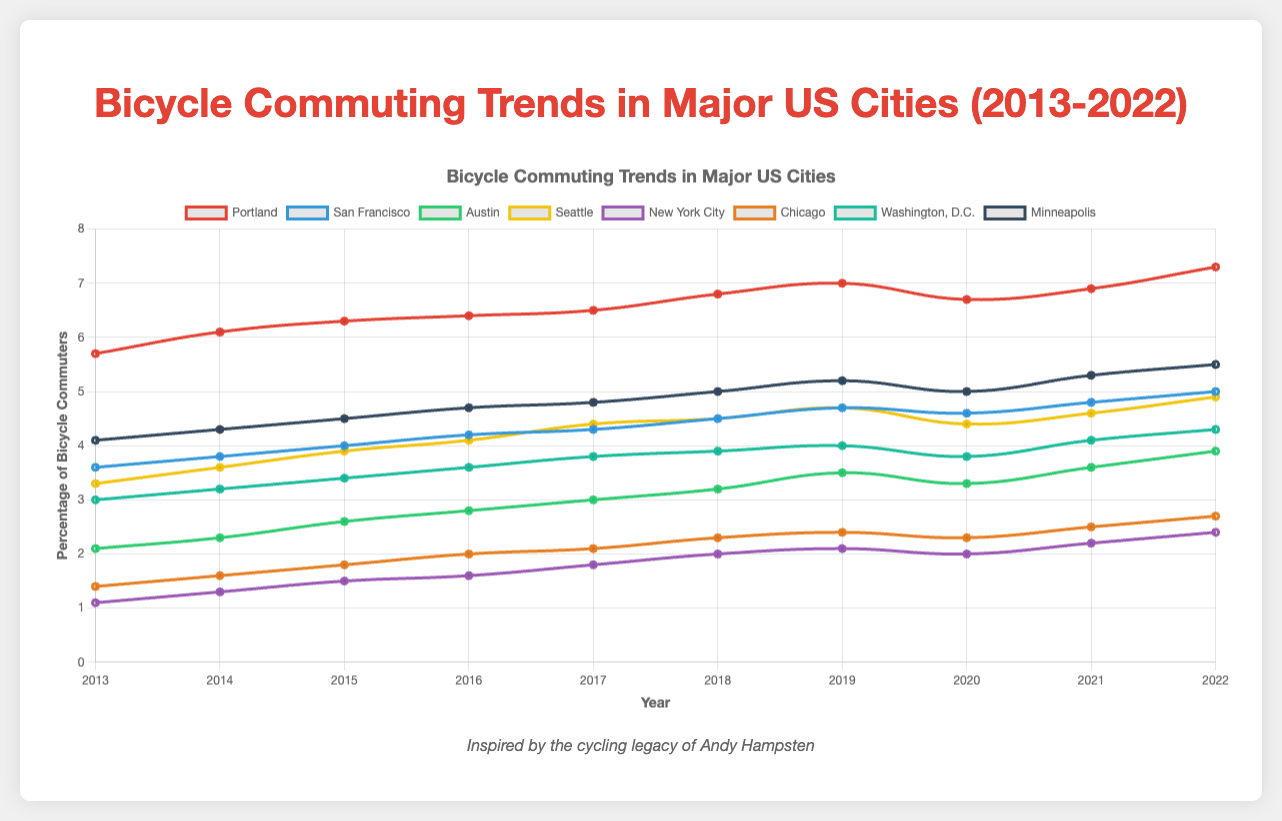What city shows the highest percentage of bicycle commuters in 2022? Look at the end points of all the lines on the right side of the graph. Portland has the highest percentage in 2022 which is 7.3%.
Answer: Portland How did the bicycle commuting rates change in San Francisco from 2013 to 2022? Compare the starting point in 2013 (3.6%) with the ending point in 2022 (5.0%) for San Francisco. The rate increased from 3.6% to 5.0%.
Answer: Increased from 3.6% to 5.0% Which city experienced the biggest drop in bicycle commuting rates in any given year? Check for the biggest single-year decrease in the lines. Portland had the biggest drop from 7.0% in 2019 to 6.7% in 2020.
Answer: Portland Between 2016 and 2018, which city had the highest average bicycle commuting rate? Identify the rates for 2016, 2017, and 2018 for each city, sum them up, and divide by 3. Portland's average is the highest at (6.4% + 6.5% + 6.8%) / 3 = 6.57%.
Answer: Portland Which two cities had a similar trend in bicycle commuting rates between 2019 and 2022? Compare the slopes and shapes of the lines from 2019 to 2022. Austin and Seattle have similar increasing trends.
Answer: Austin and Seattle Which city's bicycle commuting rate never decreased from year to year over the decade? Look for a line that continuously moves upward without any drops. San Francisco does not show any year-to-year decreases.
Answer: San Francisco What is the combined bicycle commuting rate of New York City and Chicago in 2015? Sum the percentages of New York City (1.5%) and Chicago (1.8%) in 2015. Combined rate is 1.5% + 1.8% = 3.3%.
Answer: 3.3% How many cities had a bicycle commuting rate greater than 2.0% in 2013? Count the lines that are above the 2.0% horizontal line in 2013. There are five cities: Portland, San Francisco, Seattle, Washington, D.C., and Minneapolis.
Answer: 5 Which city had the most significant percentage increase in bicycle commuting rate from 2013 to 2022? Calculate the difference between 2022 and 2013 for each city and find the maximum. Portland increased from 5.7% to 7.3%, which is a 1.6 percentage point increase, the highest among all cities.
Answer: Portland 